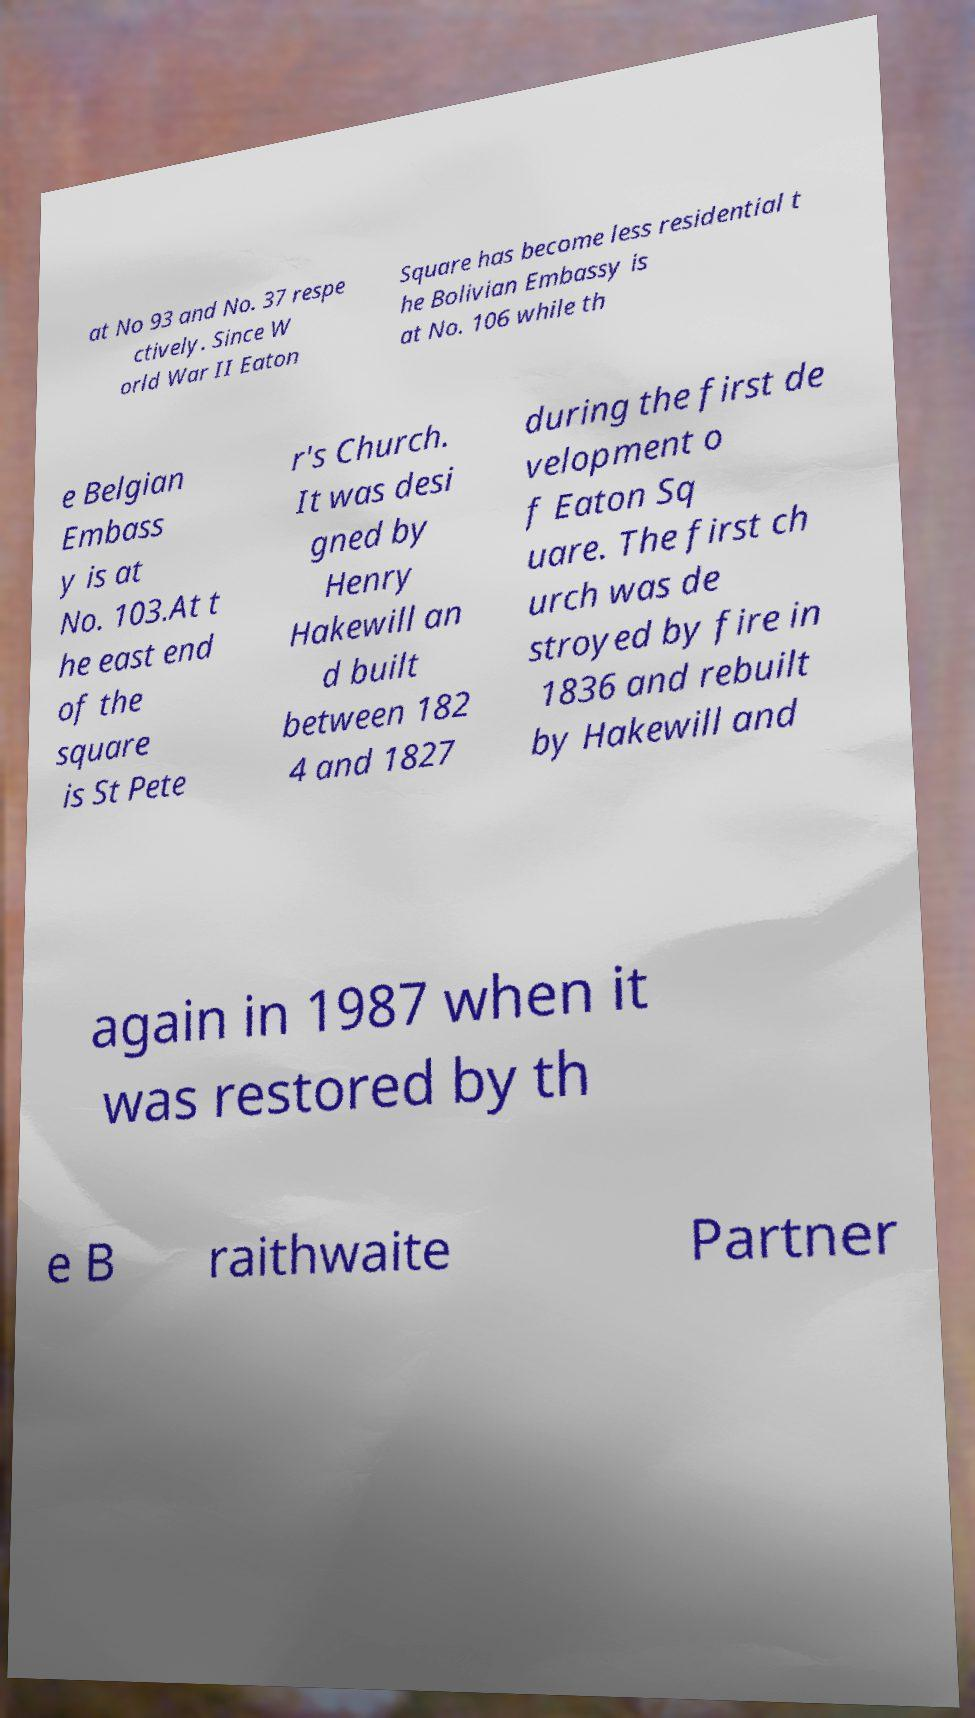Please identify and transcribe the text found in this image. at No 93 and No. 37 respe ctively. Since W orld War II Eaton Square has become less residential t he Bolivian Embassy is at No. 106 while th e Belgian Embass y is at No. 103.At t he east end of the square is St Pete r's Church. It was desi gned by Henry Hakewill an d built between 182 4 and 1827 during the first de velopment o f Eaton Sq uare. The first ch urch was de stroyed by fire in 1836 and rebuilt by Hakewill and again in 1987 when it was restored by th e B raithwaite Partner 